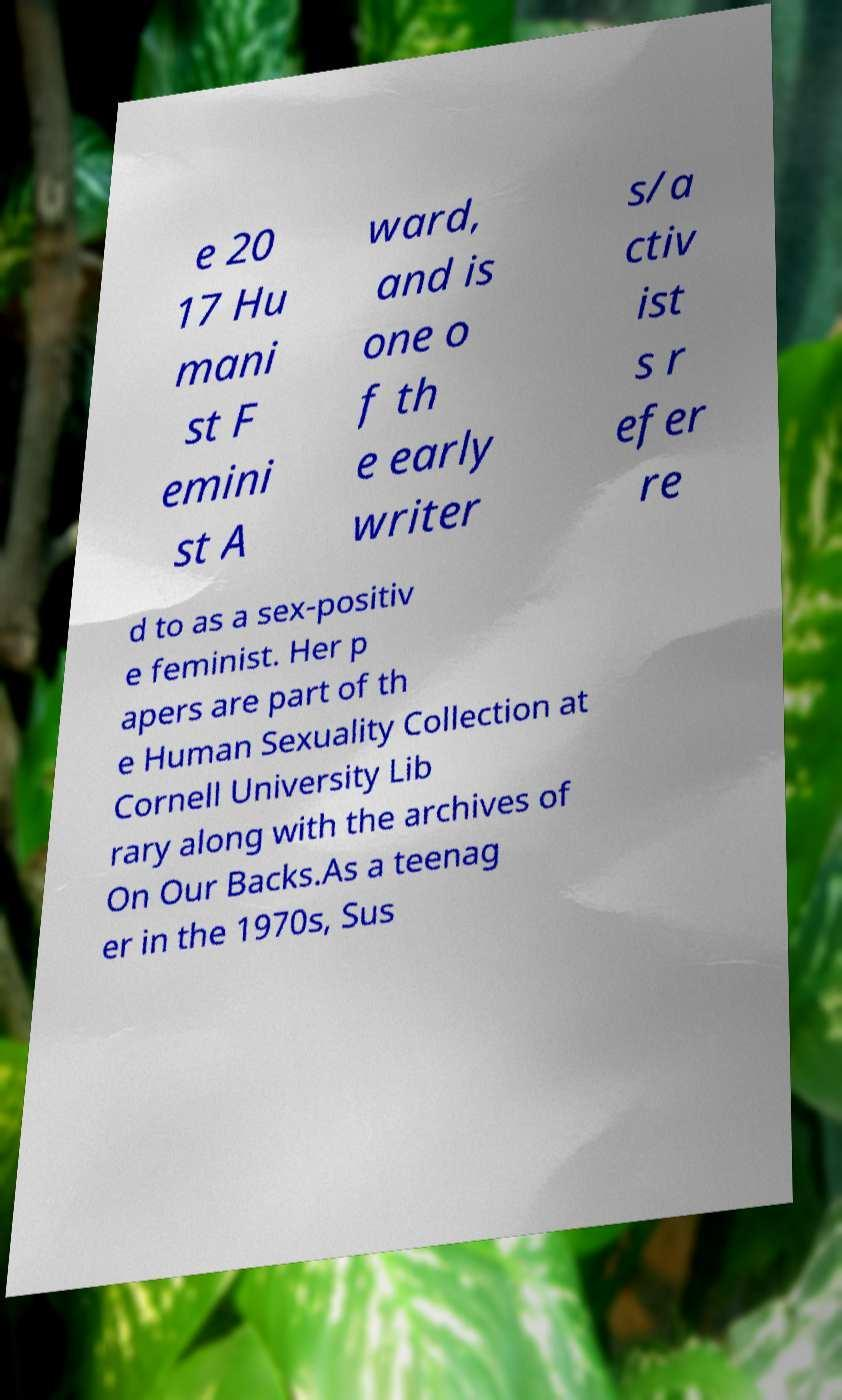There's text embedded in this image that I need extracted. Can you transcribe it verbatim? e 20 17 Hu mani st F emini st A ward, and is one o f th e early writer s/a ctiv ist s r efer re d to as a sex-positiv e feminist. Her p apers are part of th e Human Sexuality Collection at Cornell University Lib rary along with the archives of On Our Backs.As a teenag er in the 1970s, Sus 